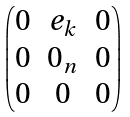Convert formula to latex. <formula><loc_0><loc_0><loc_500><loc_500>\begin{pmatrix} 0 & e _ { k } & 0 \\ 0 & 0 _ { n } & 0 \\ 0 & 0 & 0 \end{pmatrix}</formula> 